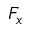<formula> <loc_0><loc_0><loc_500><loc_500>F _ { x }</formula> 